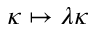<formula> <loc_0><loc_0><loc_500><loc_500>\kappa \mapsto \lambda \kappa</formula> 